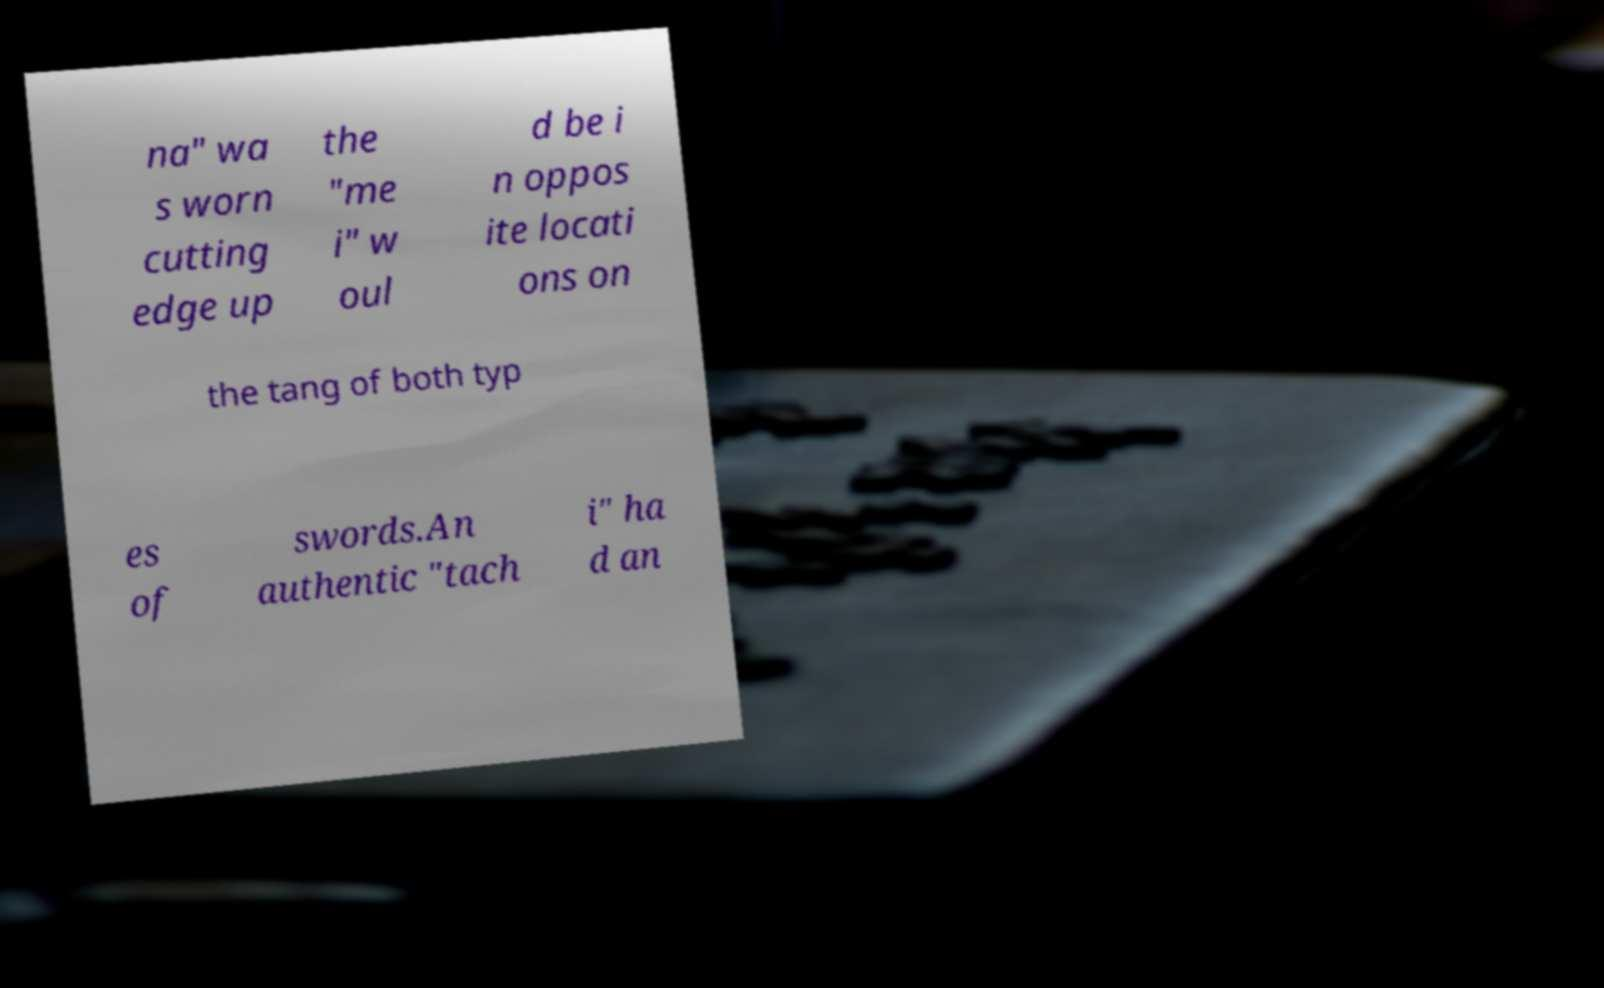Please read and relay the text visible in this image. What does it say? na" wa s worn cutting edge up the "me i" w oul d be i n oppos ite locati ons on the tang of both typ es of swords.An authentic "tach i" ha d an 